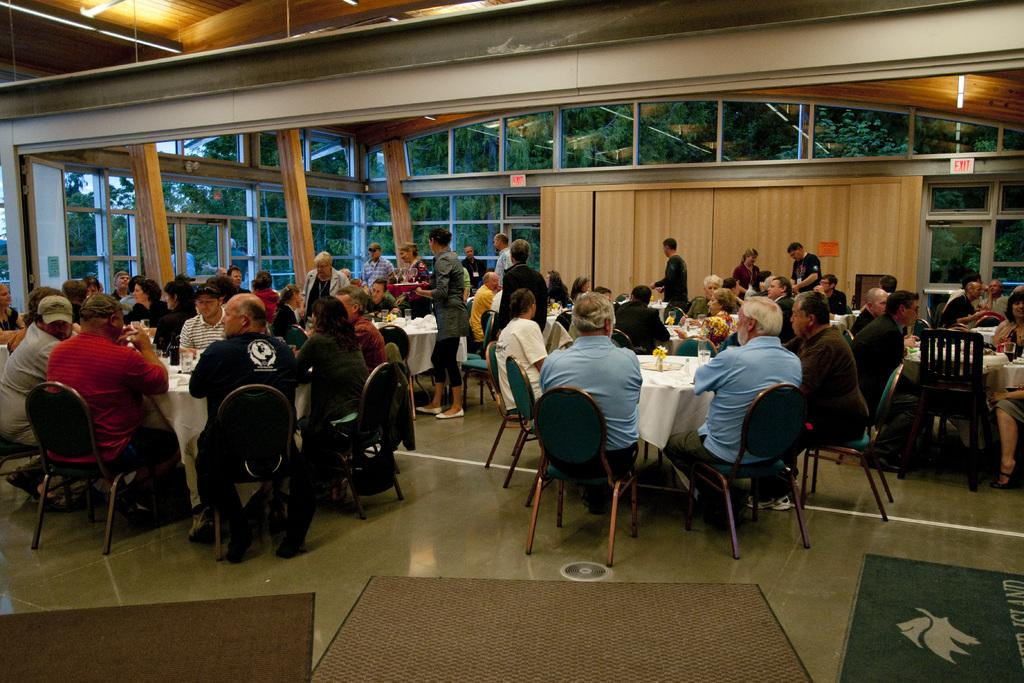How many people are in the image? There is a group of people in the image. What are the people in the image doing? The people are seated in a room. Are there any people standing in the image? Yes, there are people standing in the image. What furniture can be seen in the room? There are tables in the room. How many wrens are perched on the tables in the image? There are no wrens present in the image; it only features a group of people seated and standing in a room with tables. What type of story are the people telling each other in the image? There is no indication in the image that the people are telling a story or engaging in any specific conversation. 